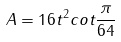<formula> <loc_0><loc_0><loc_500><loc_500>A = 1 6 t ^ { 2 } c o t \frac { \pi } { 6 4 }</formula> 